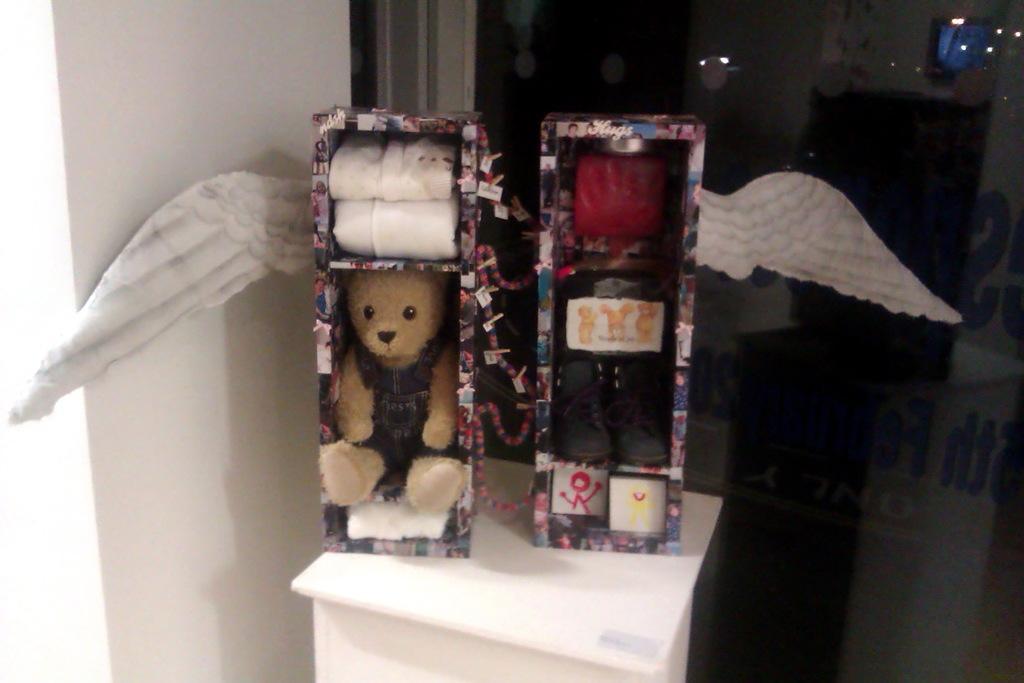How would you summarize this image in a sentence or two? In this image, on the left, there is a teddy inside the box and on the right, we can see shoes in the box. 